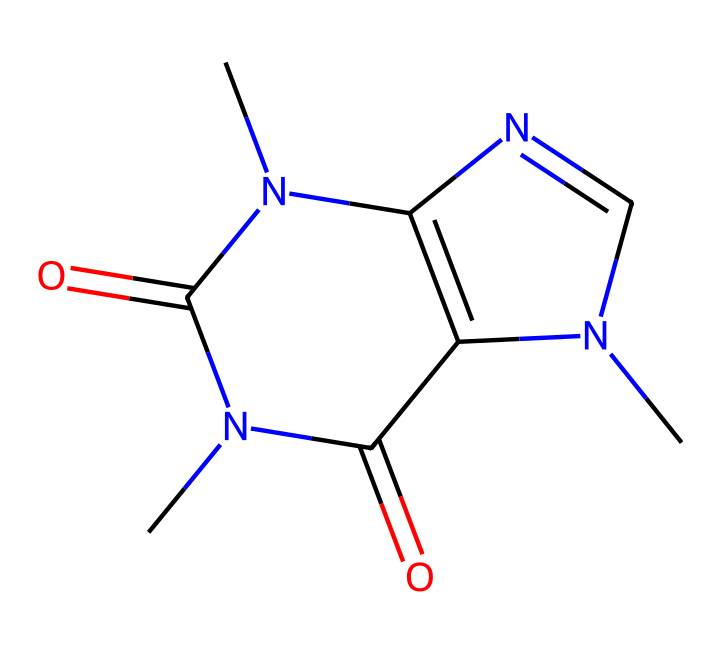what is the molecular formula of caffeine? By analyzing the structure provided in the SMILES representation, we can identify the elements present and count their respective atoms: there are 8 carbon (C) atoms, 10 hydrogen (H) atoms, 4 nitrogen (N) atoms, and 2 oxygen (O) atoms. Therefore, the molecular formula is C8H10N4O2.
Answer: C8H10N4O2 how many rings are present in caffeine? The structure can be analyzed by looking at the connectivity of the atoms. The SMILES notation indicates there are two nitrogen atoms that are part of cyclic structures. Following the ring closure indicators (1 and 2), we can see that caffeine has two rings.
Answer: 2 what type of compound is caffeine? Caffeine is categorized as an alkaloid, a naturally occurring compound derived from plant sources, characterized by the presence of nitrogen atoms. The presence of multiple nitrogen atoms in its structure indicates it falls into this category.
Answer: alkaloid what functional groups are present in caffeine? By examining the SMILES representation, we can identify functional groups present in the structure. The two ketone groups (C=O) and amine groups (N) can be seen in the structure. This identifies caffeine as having ketone and amine functional groups.
Answer: ketone and amine which nitrogen atom in caffeine contributes to its stimulant properties? Caffeine's stimulant properties are primarily attributed to its ability to block adenosine receptors, which is a result of the arrangement of nitrogen atoms. The position of the N atoms—especially the tertiary nitrogen—plays a critical role in interactions with biological receptors. Thus, the presence of the nitrogen in the aromatic ring is significant.
Answer: tertiary nitrogen 